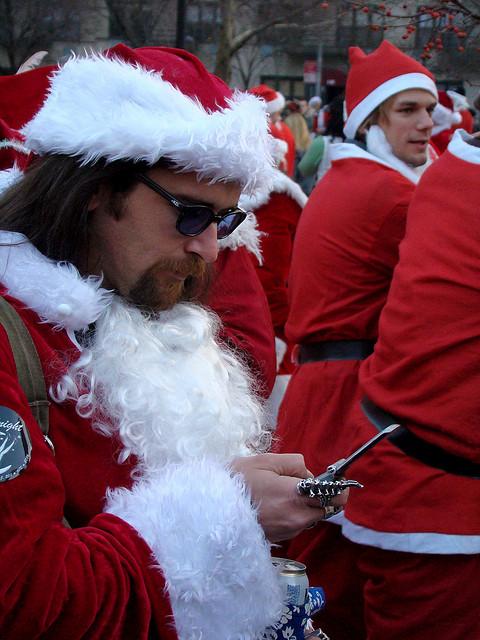What season is this?
Short answer required. Winter. Why are they all dressed in Santa suits?
Write a very short answer. Parade. Is one of the Santas wearing sunglasses?
Write a very short answer. Yes. 